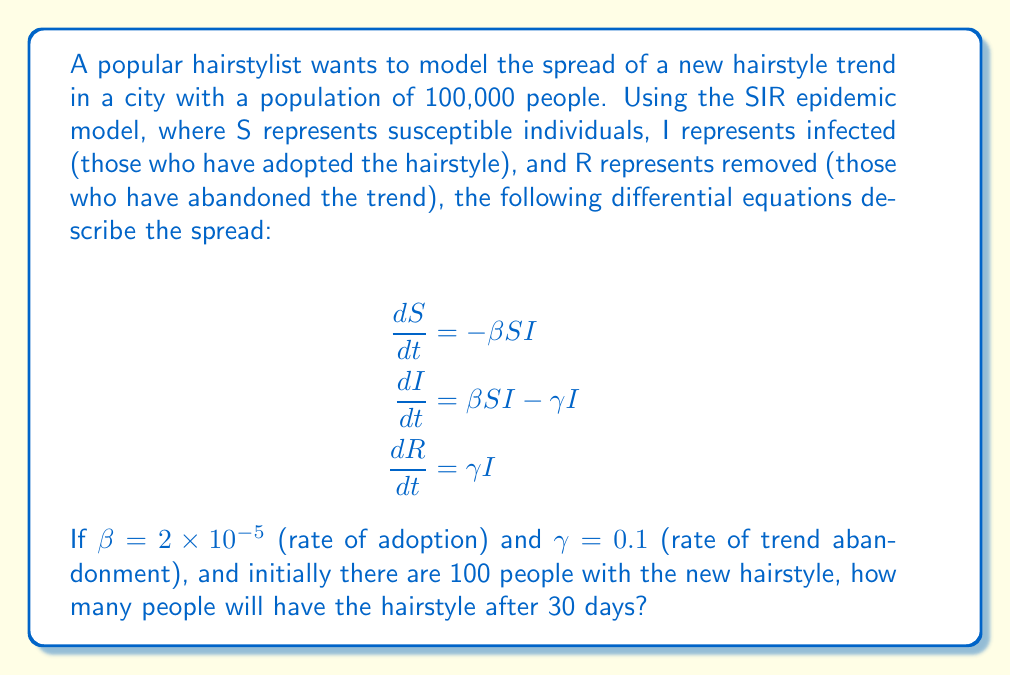Could you help me with this problem? To solve this problem, we need to use numerical methods to approximate the solution of the differential equations. We'll use the Euler method with a time step of 1 day.

Step 1: Set up initial conditions
$S_0 = 99,900$
$I_0 = 100$
$R_0 = 0$
$\Delta t = 1$ day
$T = 30$ days

Step 2: Set up the iterative equations
$$S_{n+1} = S_n - \beta S_n I_n \Delta t$$
$$I_{n+1} = I_n + (\beta S_n I_n - \gamma I_n) \Delta t$$
$$R_{n+1} = R_n + \gamma I_n \Delta t$$

Step 3: Iterate for 30 days
We'll use a loop to calculate the values for each day:

```
for n in range(30):
    S_next = S - beta * S * I * dt
    I_next = I + (beta * S * I - gamma * I) * dt
    R_next = R + gamma * I * dt
    
    S, I, R = S_next, I_next, R_next
```

Step 4: Calculate the final values
After running the loop, we get:
$S_{30} \approx 62,026$
$I_{30} \approx 24,174$
$R_{30} \approx 13,800$

The number of people with the hairstyle after 30 days is approximately 24,174.
Answer: 24,174 people 